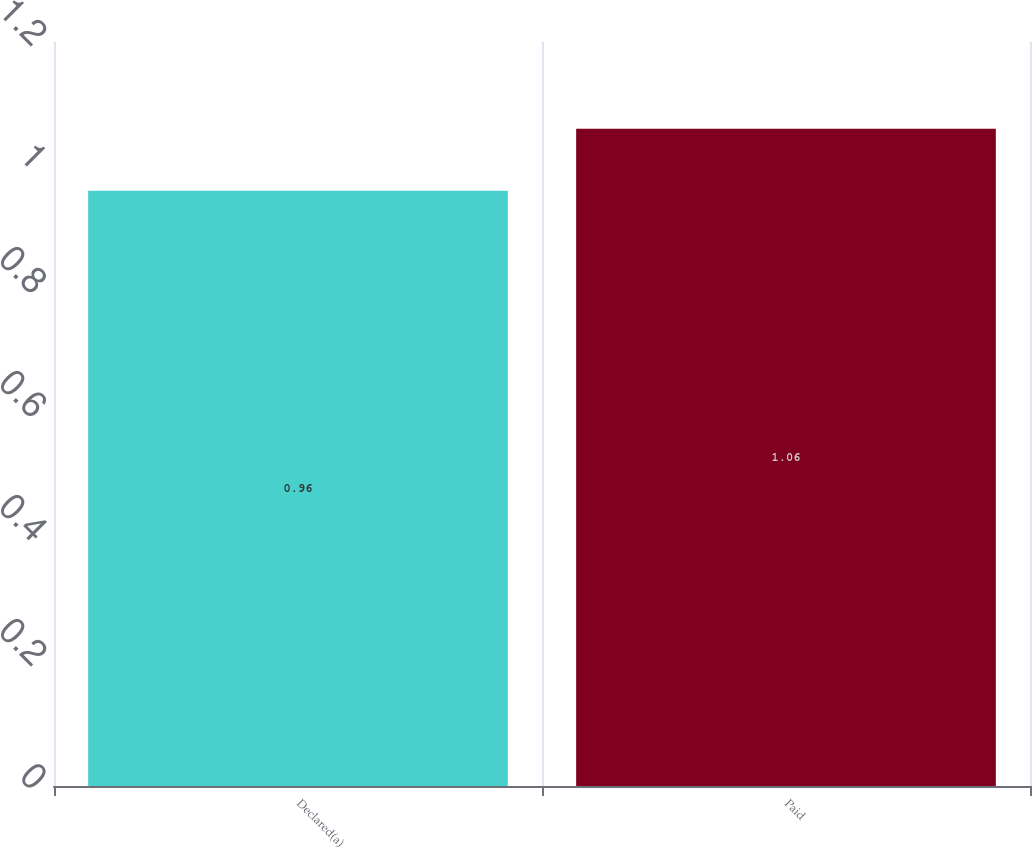Convert chart to OTSL. <chart><loc_0><loc_0><loc_500><loc_500><bar_chart><fcel>Declared(a)<fcel>Paid<nl><fcel>0.96<fcel>1.06<nl></chart> 